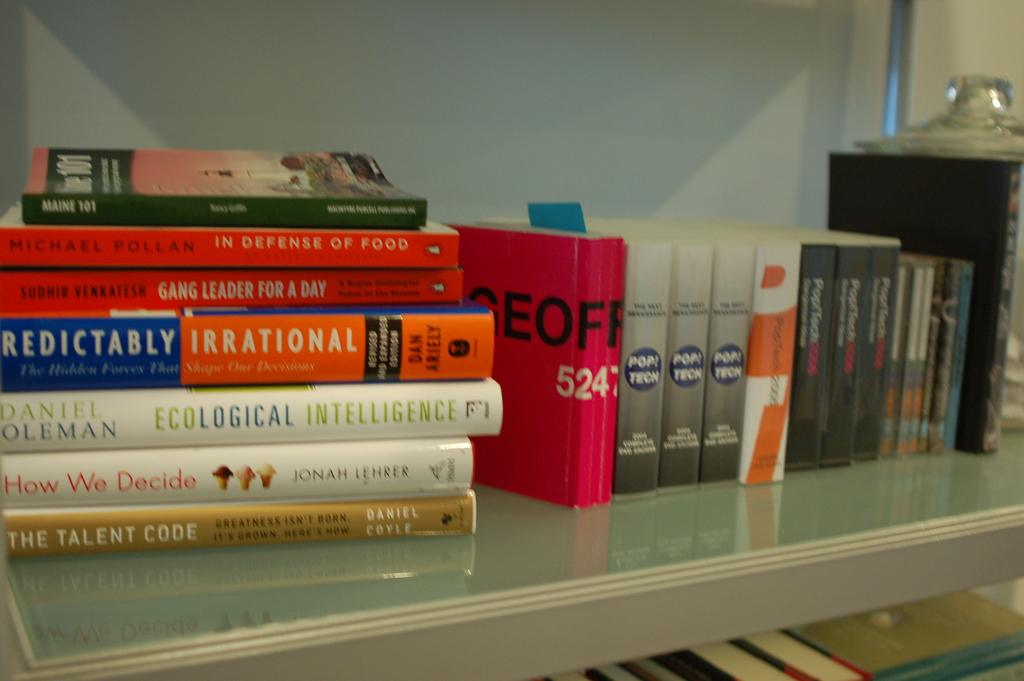<image>
Provide a brief description of the given image. Books on display on a table including one that says "How we decide". 